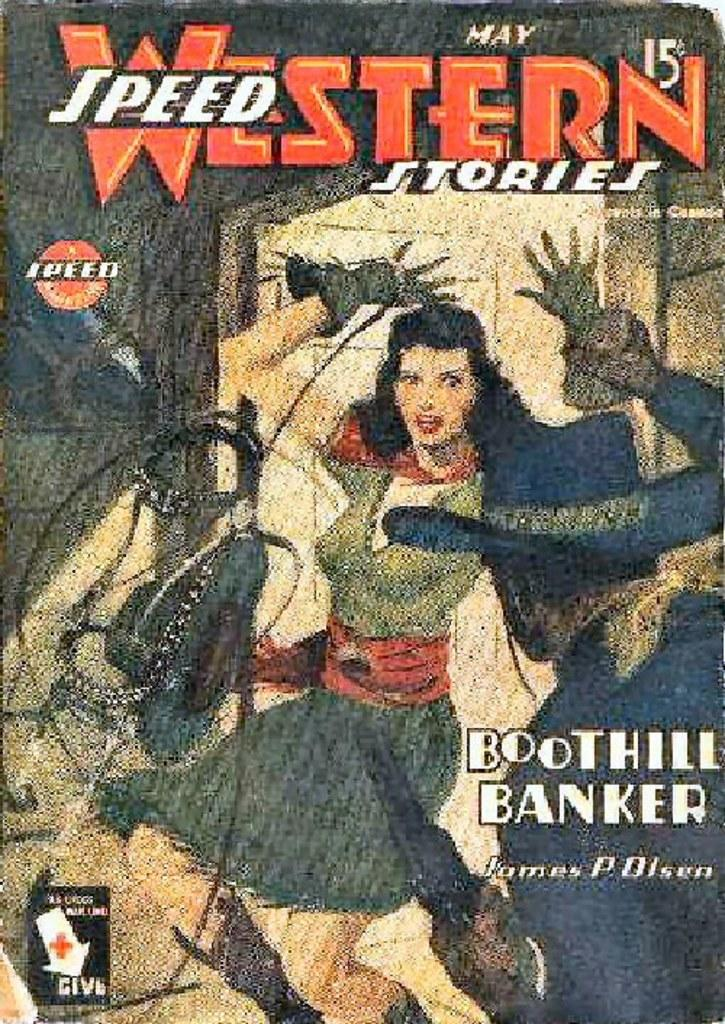<image>
Write a terse but informative summary of the picture. a poster that says ''speed western stories' on it 